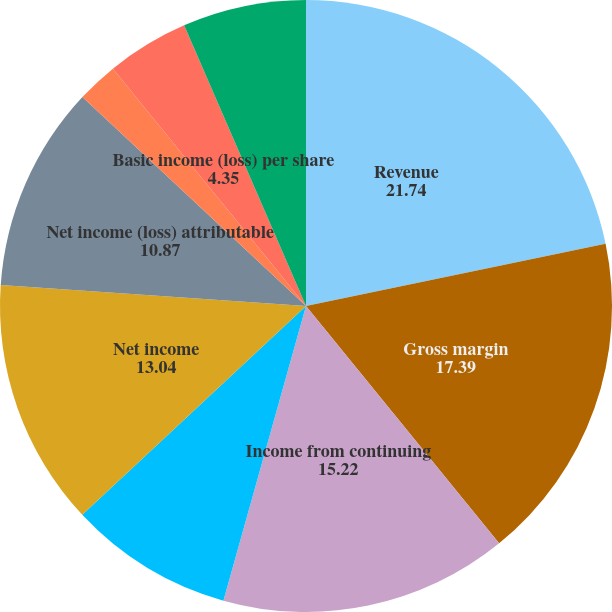Convert chart. <chart><loc_0><loc_0><loc_500><loc_500><pie_chart><fcel>Revenue<fcel>Gross margin<fcel>Income from continuing<fcel>Discontinued operations net of<fcel>Net income<fcel>Net income (loss) attributable<fcel>Income (loss) from continuing<fcel>Discontinued operations<fcel>Basic income (loss) per share<fcel>Diluted income (loss) per<nl><fcel>21.74%<fcel>17.39%<fcel>15.22%<fcel>8.7%<fcel>13.04%<fcel>10.87%<fcel>0.0%<fcel>2.17%<fcel>4.35%<fcel>6.52%<nl></chart> 